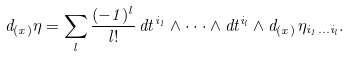Convert formula to latex. <formula><loc_0><loc_0><loc_500><loc_500>d _ { ( x ) } \eta = \sum _ { l } \frac { ( - 1 ) ^ { l } } { l ! } \, d t ^ { i _ { 1 } } \wedge \cdot \cdot \cdot \wedge d t ^ { i _ { l } } \wedge d _ { ( x ) } \, \eta _ { i _ { 1 } \dots i _ { l } } .</formula> 